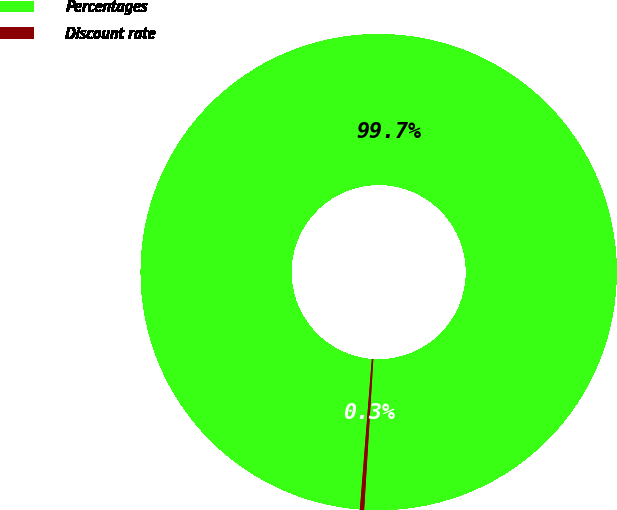Convert chart to OTSL. <chart><loc_0><loc_0><loc_500><loc_500><pie_chart><fcel>Percentages<fcel>Discount rate<nl><fcel>99.71%<fcel>0.29%<nl></chart> 